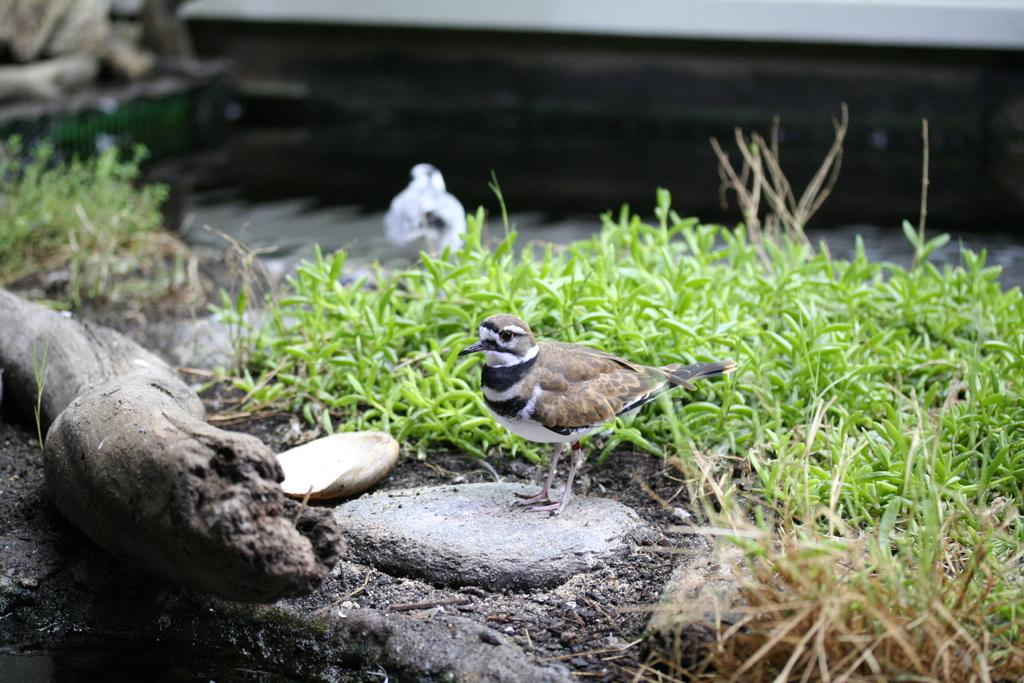What is the main subject in the center of the image? There is a bird in the center of the image. What type of vegetation is at the bottom of the image? There is grass at the bottom of the image. Can you describe the bird in the background of the image? There is another bird in the background of the image. What else can be seen in the background of the image? There are objects visible in the background of the image. What type of powder is being used to create the boundary in the image? There is no powder or boundary present in the image; it features a bird in the center, grass at the bottom, and another bird and objects in the background. 